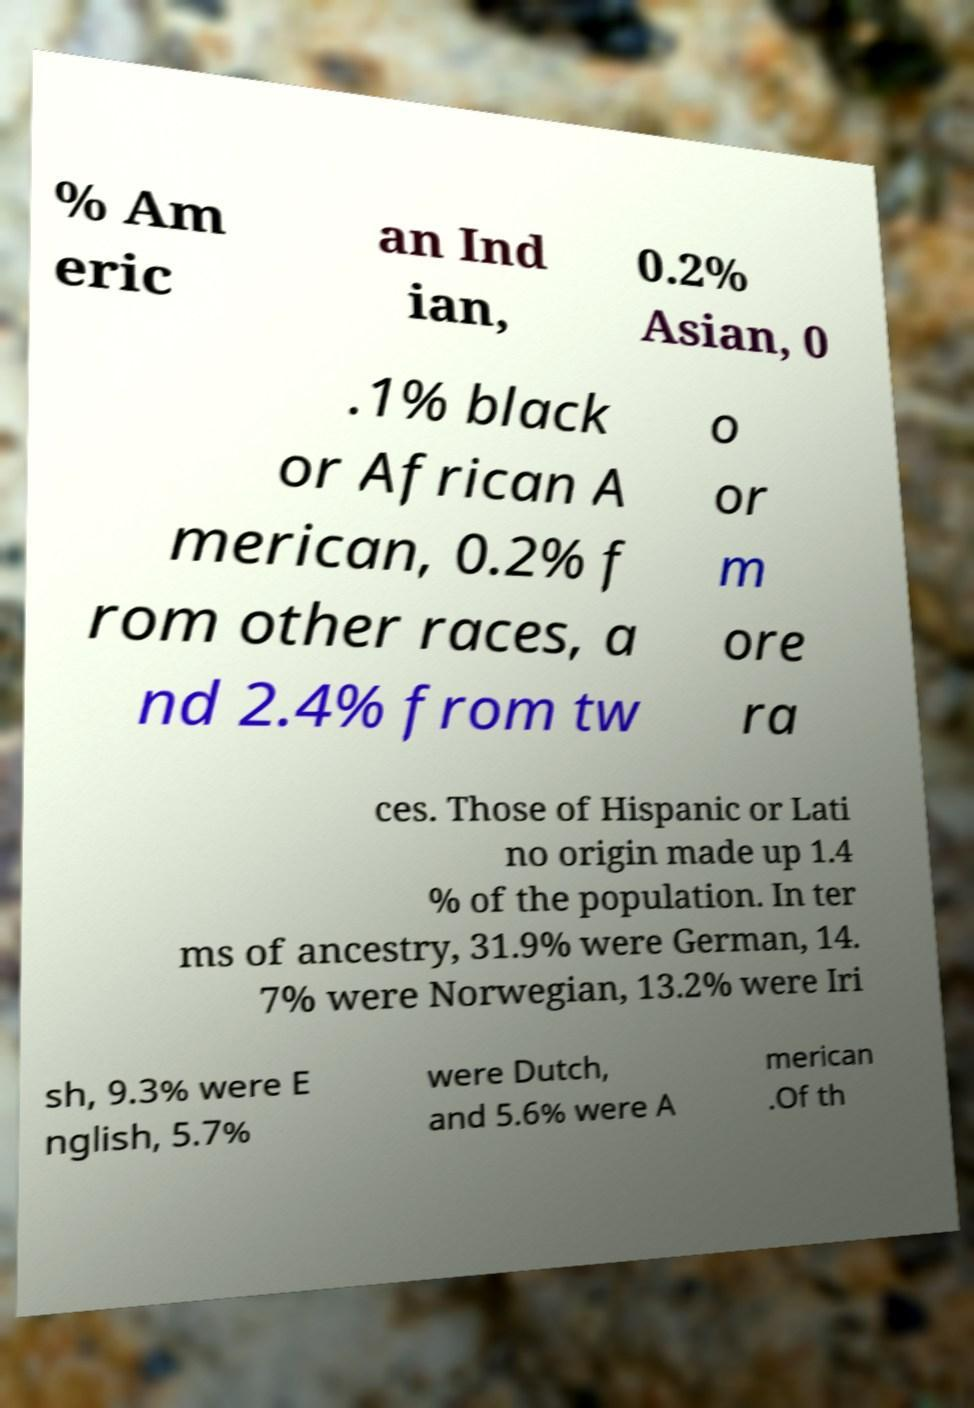Can you read and provide the text displayed in the image?This photo seems to have some interesting text. Can you extract and type it out for me? % Am eric an Ind ian, 0.2% Asian, 0 .1% black or African A merican, 0.2% f rom other races, a nd 2.4% from tw o or m ore ra ces. Those of Hispanic or Lati no origin made up 1.4 % of the population. In ter ms of ancestry, 31.9% were German, 14. 7% were Norwegian, 13.2% were Iri sh, 9.3% were E nglish, 5.7% were Dutch, and 5.6% were A merican .Of th 